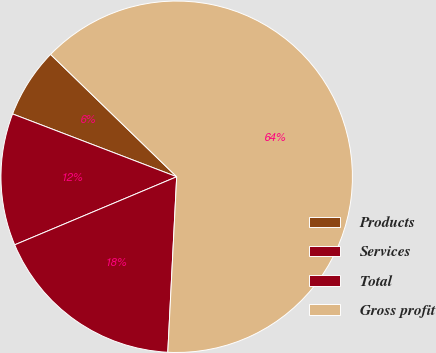Convert chart. <chart><loc_0><loc_0><loc_500><loc_500><pie_chart><fcel>Products<fcel>Services<fcel>Total<fcel>Gross profit<nl><fcel>6.44%<fcel>12.15%<fcel>17.86%<fcel>63.54%<nl></chart> 